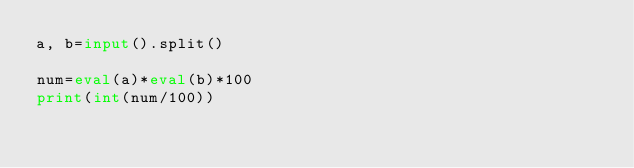<code> <loc_0><loc_0><loc_500><loc_500><_Python_>a, b=input().split()

num=eval(a)*eval(b)*100
print(int(num/100))</code> 